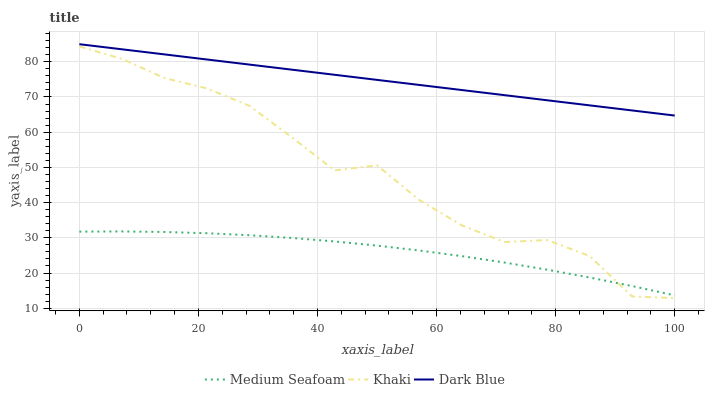Does Medium Seafoam have the minimum area under the curve?
Answer yes or no. Yes. Does Dark Blue have the maximum area under the curve?
Answer yes or no. Yes. Does Khaki have the minimum area under the curve?
Answer yes or no. No. Does Khaki have the maximum area under the curve?
Answer yes or no. No. Is Dark Blue the smoothest?
Answer yes or no. Yes. Is Khaki the roughest?
Answer yes or no. Yes. Is Medium Seafoam the smoothest?
Answer yes or no. No. Is Medium Seafoam the roughest?
Answer yes or no. No. Does Medium Seafoam have the lowest value?
Answer yes or no. No. Does Dark Blue have the highest value?
Answer yes or no. Yes. Does Khaki have the highest value?
Answer yes or no. No. Is Medium Seafoam less than Dark Blue?
Answer yes or no. Yes. Is Dark Blue greater than Khaki?
Answer yes or no. Yes. Does Medium Seafoam intersect Dark Blue?
Answer yes or no. No. 